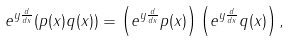Convert formula to latex. <formula><loc_0><loc_0><loc_500><loc_500>e ^ { y \frac { d } { d x } } ( p ( x ) q ( x ) ) = \left ( e ^ { y \frac { d } { d x } } p ( x ) \right ) \left ( e ^ { y \frac { d } { d x } } q ( x ) \right ) ,</formula> 